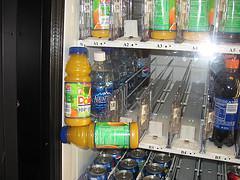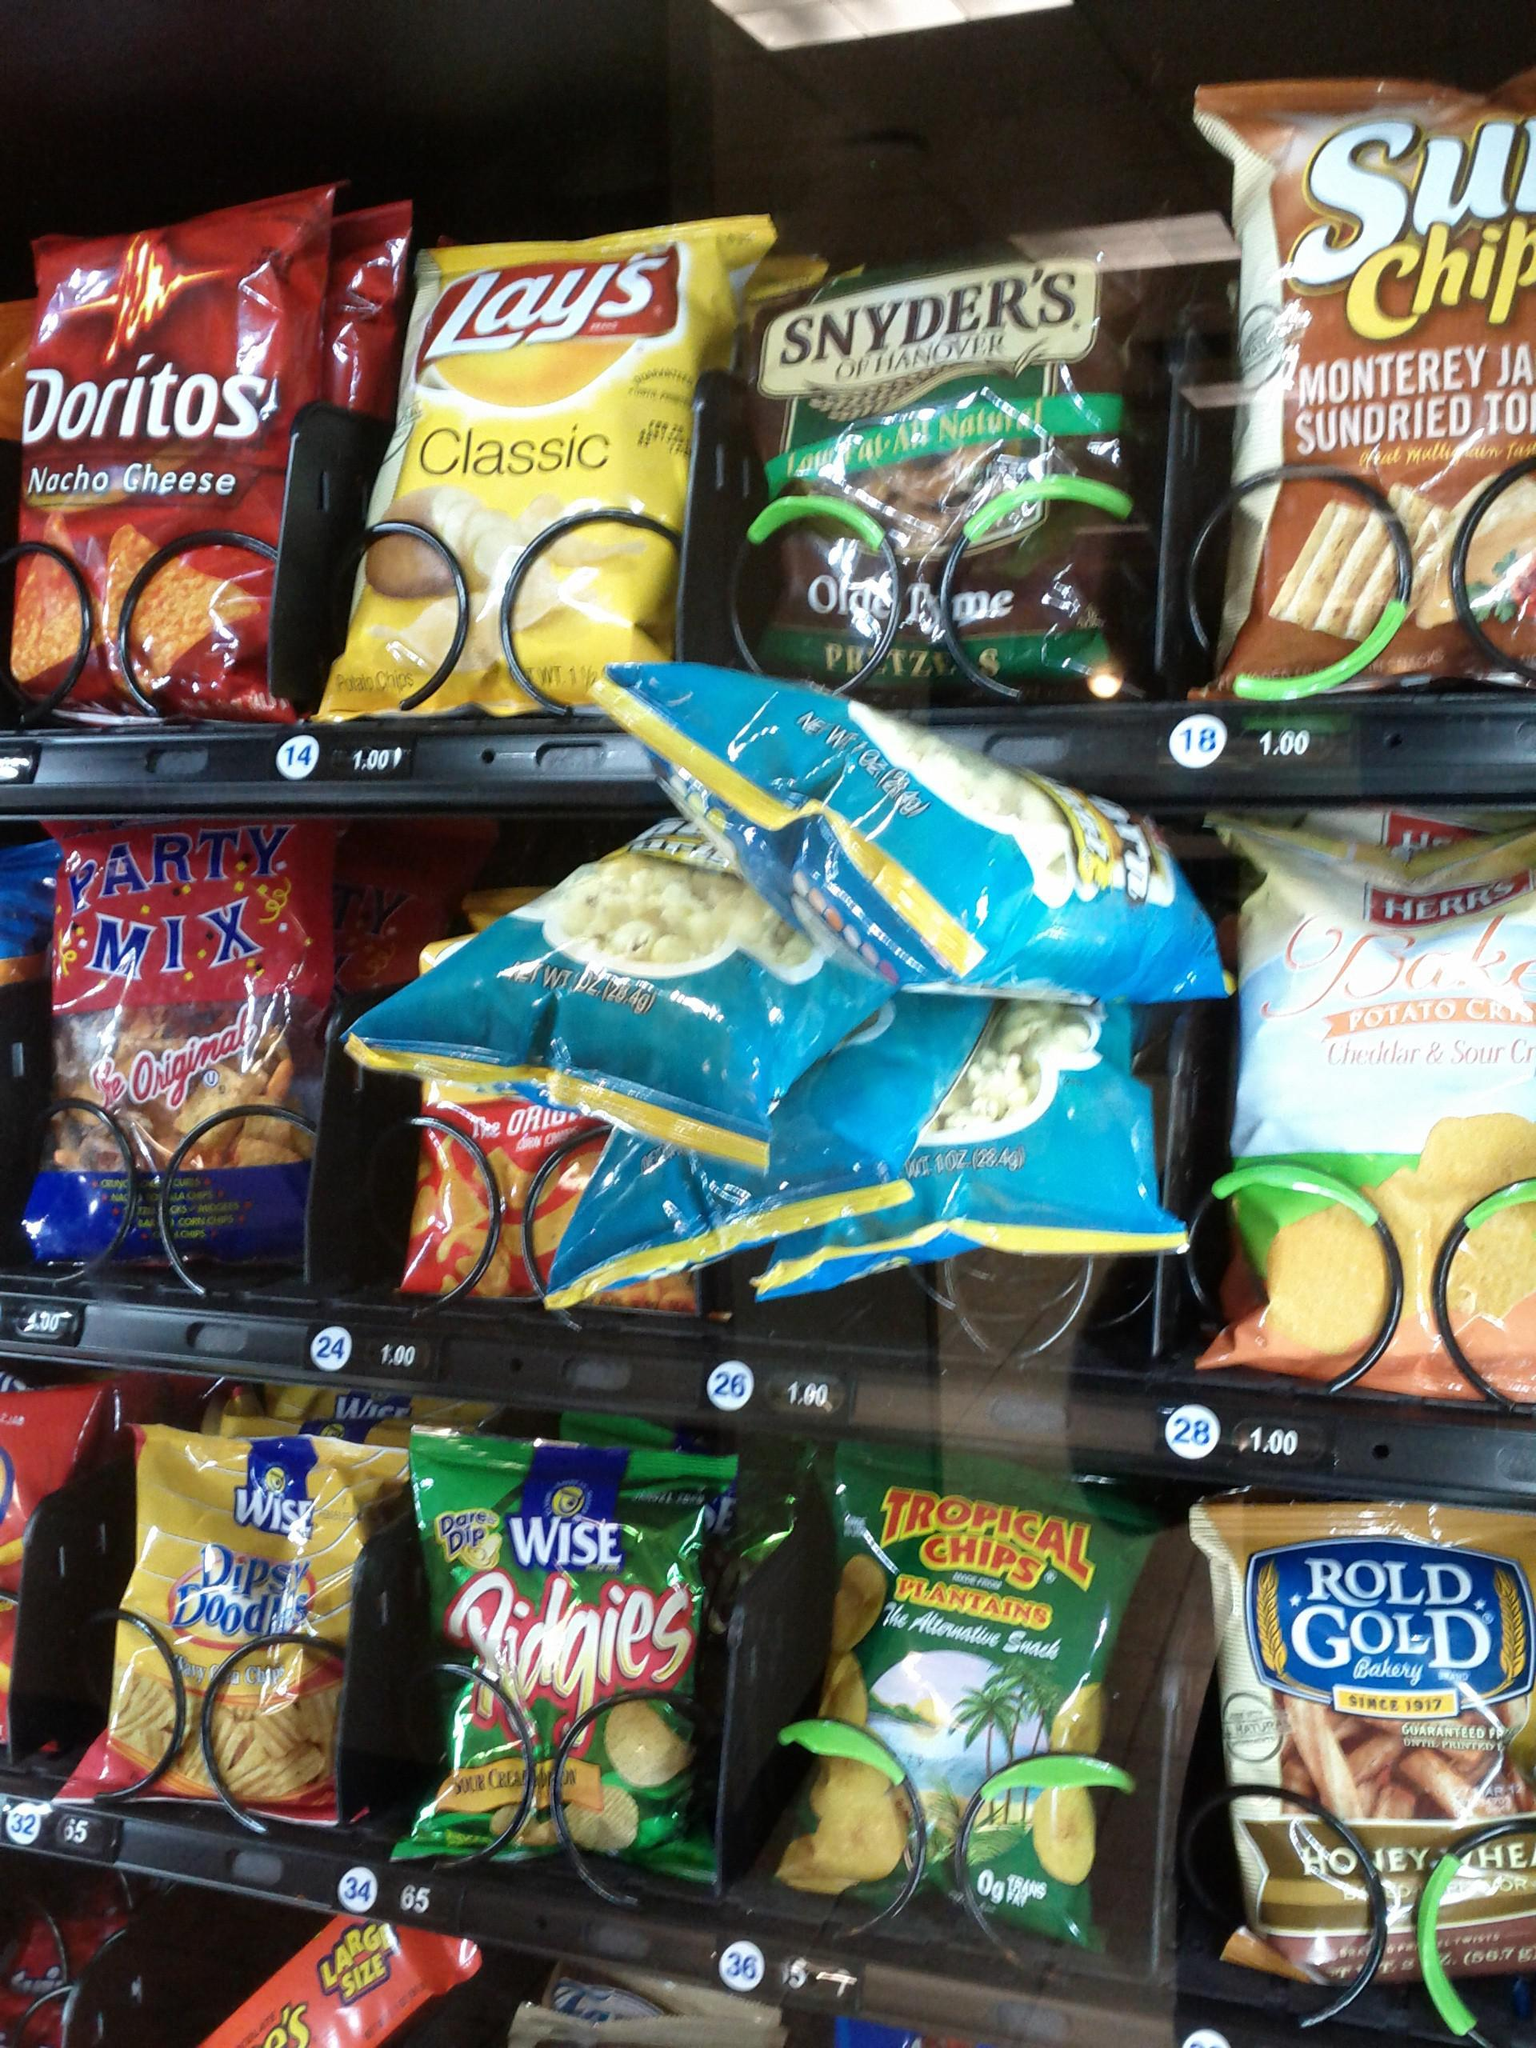The first image is the image on the left, the second image is the image on the right. For the images displayed, is the sentence "At least one of the images shows snacks that have got stuck in a vending machine." factually correct? Answer yes or no. Yes. The first image is the image on the left, the second image is the image on the right. Assess this claim about the two images: "There are items falling from their shelves in both images.". Correct or not? Answer yes or no. Yes. 